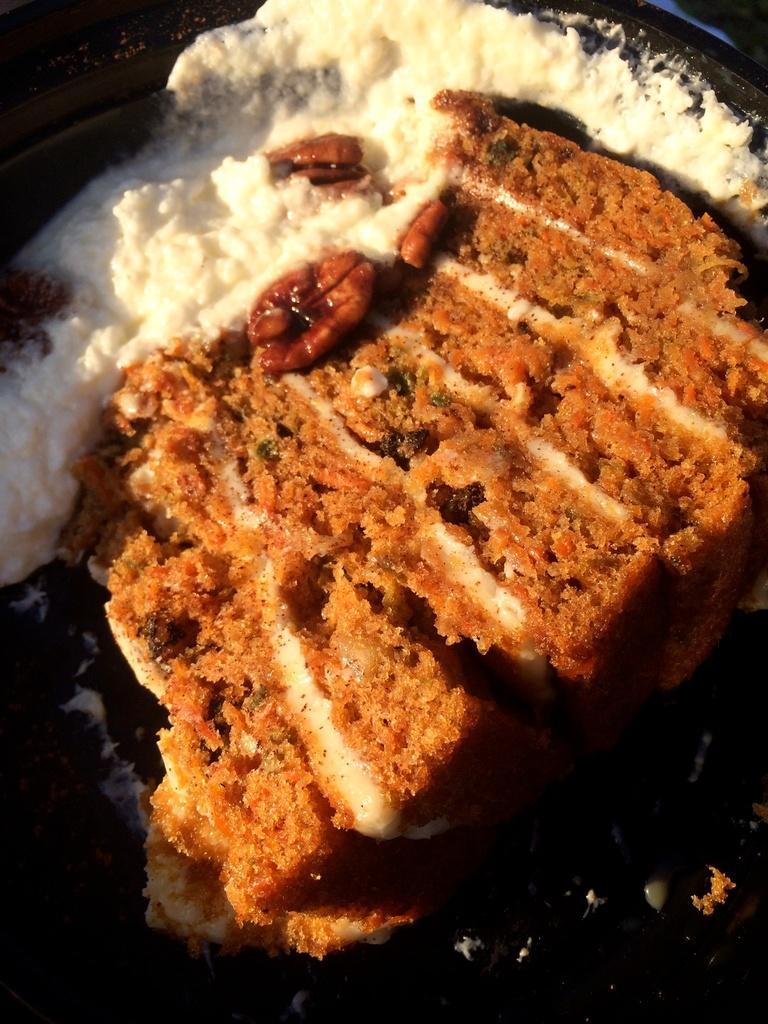How would you summarize this image in a sentence or two? In this image, we can see some food. 